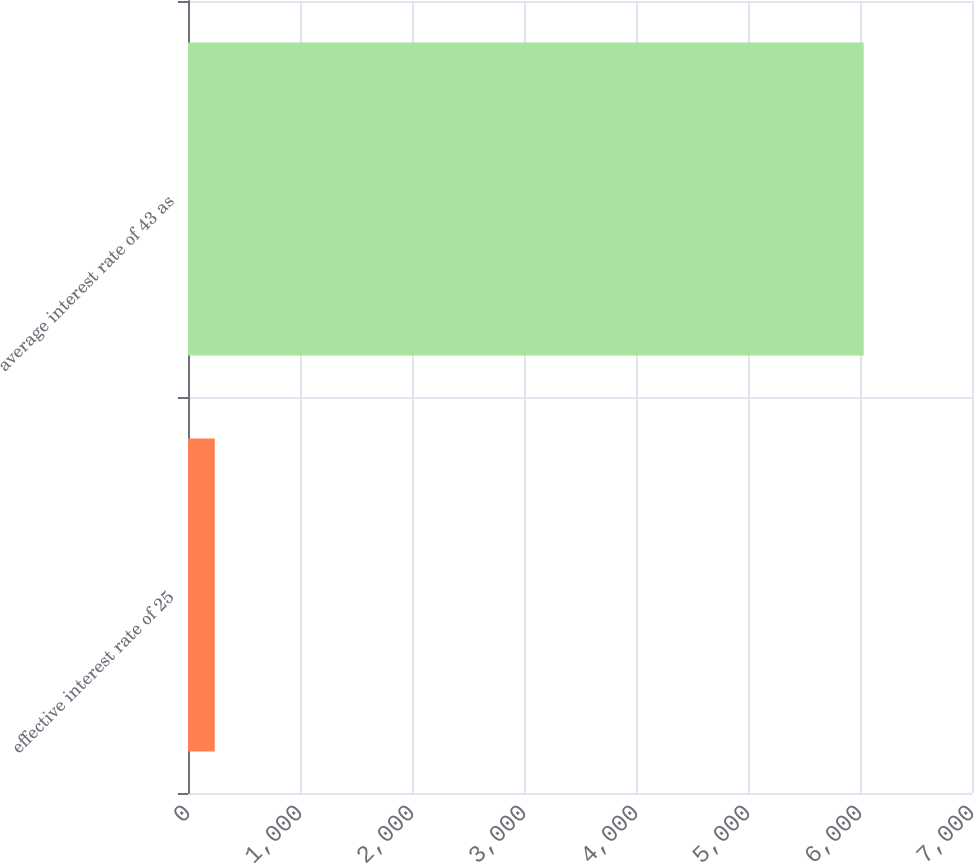<chart> <loc_0><loc_0><loc_500><loc_500><bar_chart><fcel>effective interest rate of 25<fcel>average interest rate of 43 as<nl><fcel>239<fcel>6033<nl></chart> 